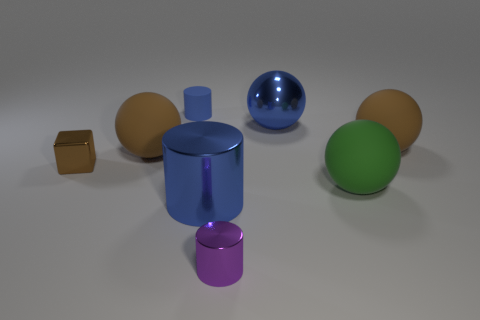Is the color of the metal sphere the same as the small matte cylinder?
Offer a terse response. Yes. Does the tiny cylinder that is to the left of the purple shiny thing have the same material as the big ball in front of the tiny shiny cube?
Ensure brevity in your answer.  Yes. Are there more gray rubber cylinders than large rubber things?
Provide a succinct answer. No. Is there any other thing of the same color as the big shiny sphere?
Your answer should be compact. Yes. Is the material of the small brown object the same as the purple cylinder?
Your answer should be compact. Yes. Are there fewer small brown things than big red matte objects?
Your answer should be compact. No. Does the purple metallic object have the same shape as the small blue object?
Give a very brief answer. Yes. What is the color of the tiny cube?
Ensure brevity in your answer.  Brown. What number of other objects are the same material as the large cylinder?
Provide a succinct answer. 3. What number of brown things are either tiny metallic objects or cubes?
Ensure brevity in your answer.  1. 